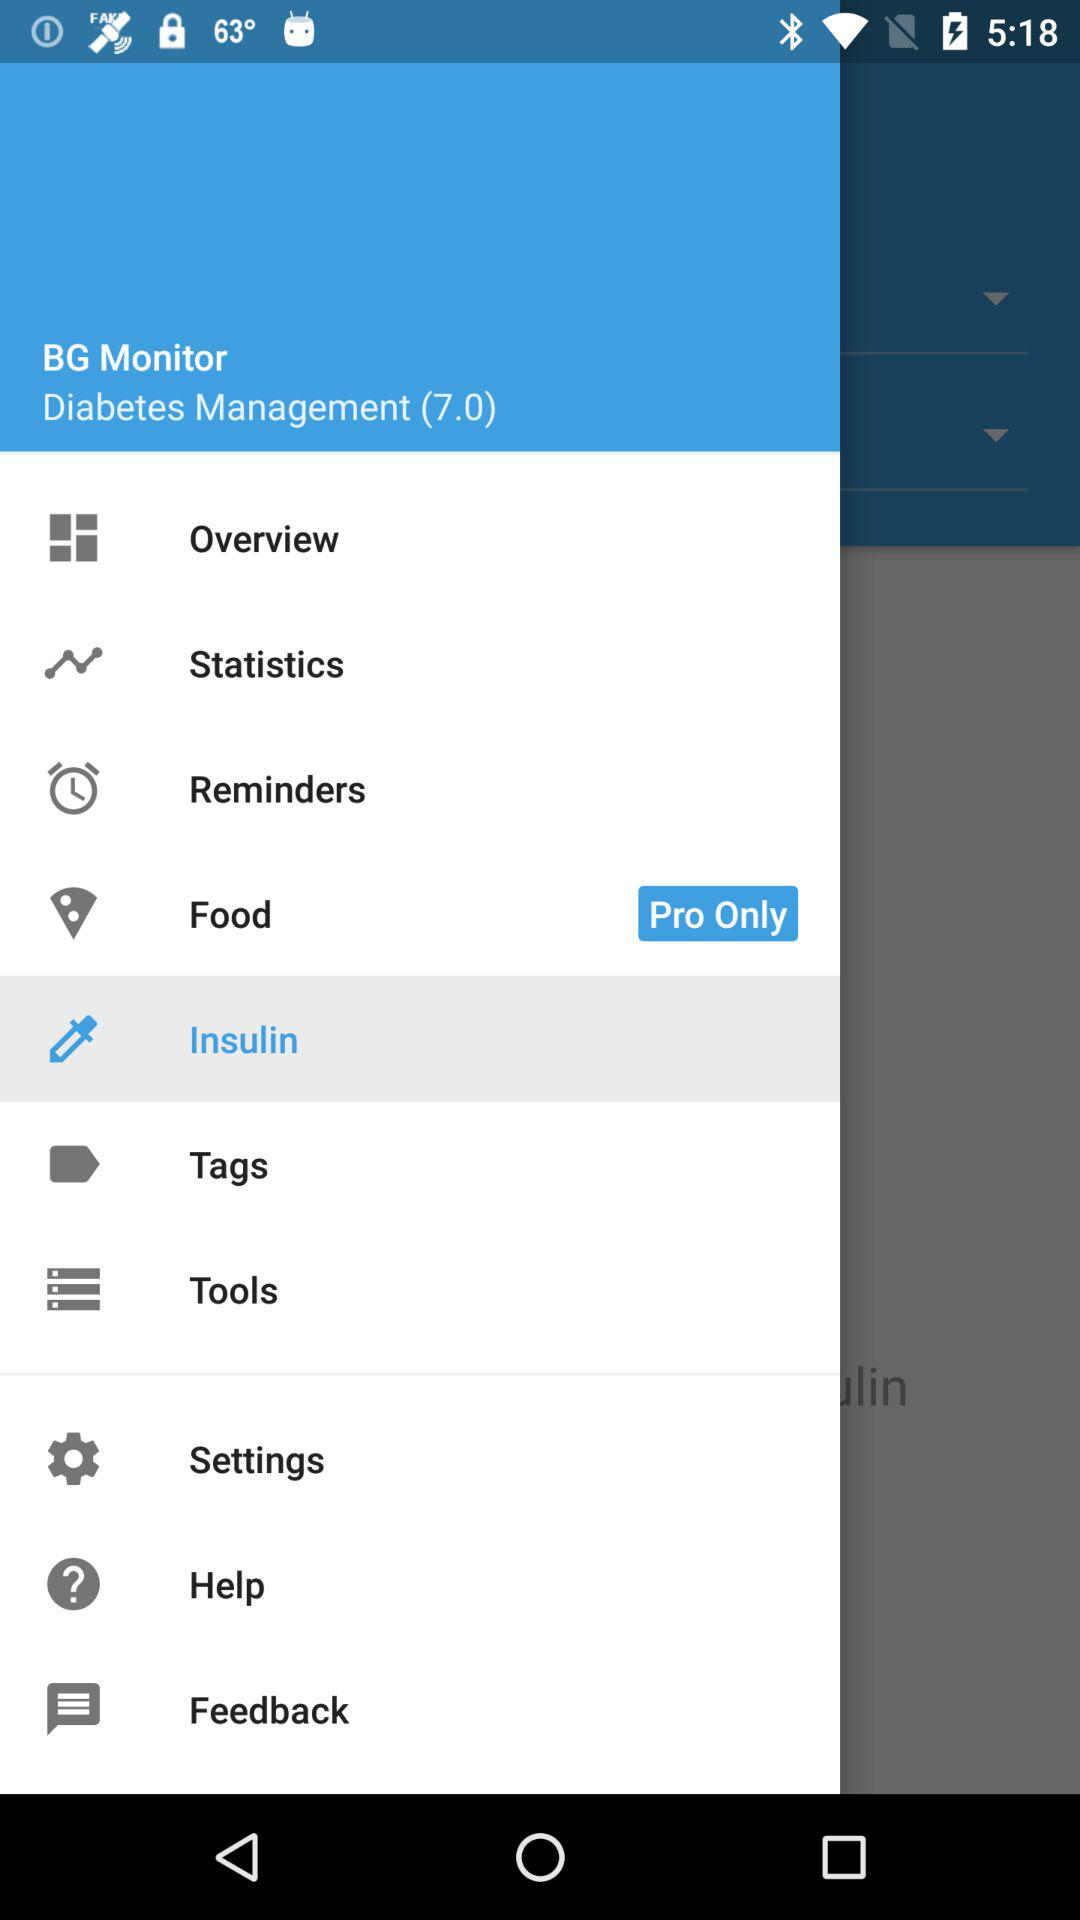What is the name of the application? The application name is "BG Monitor". 